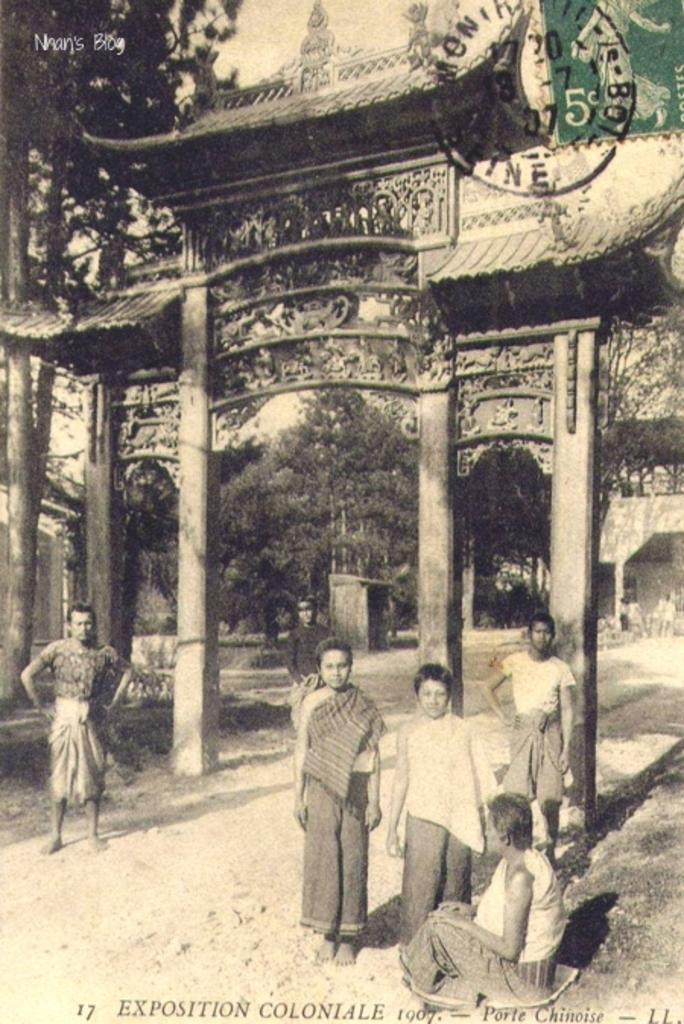What is happening in the image? There are persons standing in the image. What is located behind the persons? There is an arch behind the persons. What can be seen in the background of the image? Trees are present in the background of the image. What type of bead is being used to prepare breakfast in the image? There is no bead or breakfast present in the image. How many combs are visible in the image? There are no combs visible in the image. 